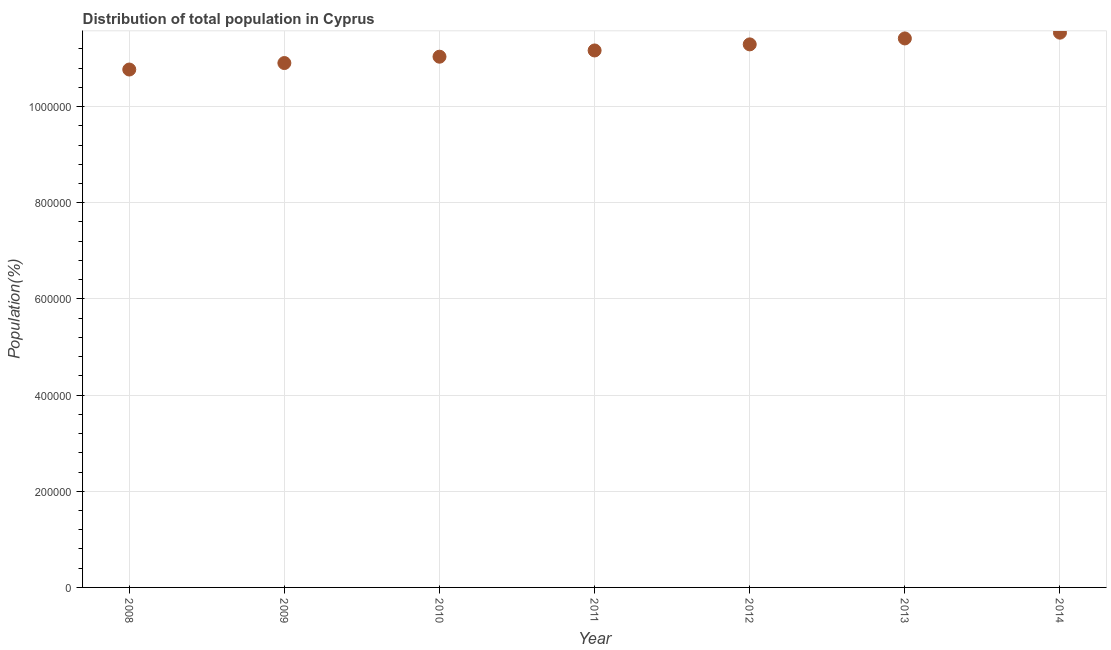What is the population in 2008?
Make the answer very short. 1.08e+06. Across all years, what is the maximum population?
Provide a short and direct response. 1.15e+06. Across all years, what is the minimum population?
Ensure brevity in your answer.  1.08e+06. In which year was the population maximum?
Make the answer very short. 2014. What is the sum of the population?
Provide a succinct answer. 7.81e+06. What is the difference between the population in 2011 and 2014?
Ensure brevity in your answer.  -3.70e+04. What is the average population per year?
Your answer should be very brief. 1.12e+06. What is the median population?
Make the answer very short. 1.12e+06. What is the ratio of the population in 2009 to that in 2014?
Make the answer very short. 0.95. Is the population in 2009 less than that in 2012?
Your answer should be compact. Yes. What is the difference between the highest and the second highest population?
Offer a very short reply. 1.20e+04. Is the sum of the population in 2010 and 2013 greater than the maximum population across all years?
Give a very brief answer. Yes. What is the difference between the highest and the lowest population?
Provide a short and direct response. 7.66e+04. In how many years, is the population greater than the average population taken over all years?
Keep it short and to the point. 4. Does the population monotonically increase over the years?
Make the answer very short. Yes. How many dotlines are there?
Your response must be concise. 1. What is the difference between two consecutive major ticks on the Y-axis?
Your response must be concise. 2.00e+05. Does the graph contain any zero values?
Provide a succinct answer. No. Does the graph contain grids?
Ensure brevity in your answer.  Yes. What is the title of the graph?
Offer a very short reply. Distribution of total population in Cyprus . What is the label or title of the Y-axis?
Give a very brief answer. Population(%). What is the Population(%) in 2008?
Make the answer very short. 1.08e+06. What is the Population(%) in 2009?
Provide a short and direct response. 1.09e+06. What is the Population(%) in 2010?
Give a very brief answer. 1.10e+06. What is the Population(%) in 2011?
Your answer should be very brief. 1.12e+06. What is the Population(%) in 2012?
Provide a succinct answer. 1.13e+06. What is the Population(%) in 2013?
Your answer should be very brief. 1.14e+06. What is the Population(%) in 2014?
Ensure brevity in your answer.  1.15e+06. What is the difference between the Population(%) in 2008 and 2009?
Give a very brief answer. -1.35e+04. What is the difference between the Population(%) in 2008 and 2010?
Give a very brief answer. -2.67e+04. What is the difference between the Population(%) in 2008 and 2011?
Make the answer very short. -3.96e+04. What is the difference between the Population(%) in 2008 and 2012?
Offer a terse response. -5.23e+04. What is the difference between the Population(%) in 2008 and 2013?
Keep it short and to the point. -6.46e+04. What is the difference between the Population(%) in 2008 and 2014?
Ensure brevity in your answer.  -7.66e+04. What is the difference between the Population(%) in 2009 and 2010?
Offer a terse response. -1.32e+04. What is the difference between the Population(%) in 2009 and 2011?
Give a very brief answer. -2.62e+04. What is the difference between the Population(%) in 2009 and 2012?
Provide a short and direct response. -3.88e+04. What is the difference between the Population(%) in 2009 and 2013?
Ensure brevity in your answer.  -5.12e+04. What is the difference between the Population(%) in 2009 and 2014?
Your answer should be very brief. -6.32e+04. What is the difference between the Population(%) in 2010 and 2011?
Provide a short and direct response. -1.30e+04. What is the difference between the Population(%) in 2010 and 2012?
Ensure brevity in your answer.  -2.56e+04. What is the difference between the Population(%) in 2010 and 2013?
Your response must be concise. -3.80e+04. What is the difference between the Population(%) in 2010 and 2014?
Your response must be concise. -5.00e+04. What is the difference between the Population(%) in 2011 and 2012?
Ensure brevity in your answer.  -1.27e+04. What is the difference between the Population(%) in 2011 and 2013?
Your answer should be very brief. -2.50e+04. What is the difference between the Population(%) in 2011 and 2014?
Offer a terse response. -3.70e+04. What is the difference between the Population(%) in 2012 and 2013?
Ensure brevity in your answer.  -1.23e+04. What is the difference between the Population(%) in 2012 and 2014?
Your answer should be very brief. -2.44e+04. What is the difference between the Population(%) in 2013 and 2014?
Your answer should be compact. -1.20e+04. What is the ratio of the Population(%) in 2008 to that in 2009?
Provide a succinct answer. 0.99. What is the ratio of the Population(%) in 2008 to that in 2011?
Keep it short and to the point. 0.96. What is the ratio of the Population(%) in 2008 to that in 2012?
Provide a succinct answer. 0.95. What is the ratio of the Population(%) in 2008 to that in 2013?
Your answer should be very brief. 0.94. What is the ratio of the Population(%) in 2008 to that in 2014?
Your answer should be very brief. 0.93. What is the ratio of the Population(%) in 2009 to that in 2011?
Ensure brevity in your answer.  0.98. What is the ratio of the Population(%) in 2009 to that in 2013?
Keep it short and to the point. 0.95. What is the ratio of the Population(%) in 2009 to that in 2014?
Your answer should be very brief. 0.94. What is the ratio of the Population(%) in 2010 to that in 2011?
Provide a short and direct response. 0.99. What is the ratio of the Population(%) in 2010 to that in 2014?
Make the answer very short. 0.96. What is the ratio of the Population(%) in 2012 to that in 2014?
Your answer should be compact. 0.98. What is the ratio of the Population(%) in 2013 to that in 2014?
Offer a terse response. 0.99. 